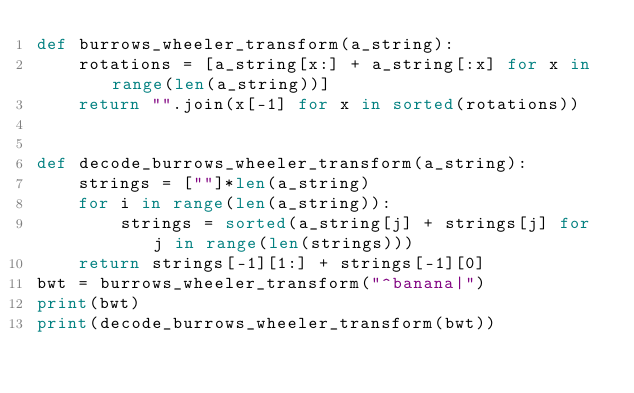Convert code to text. <code><loc_0><loc_0><loc_500><loc_500><_Python_>def burrows_wheeler_transform(a_string):
    rotations = [a_string[x:] + a_string[:x] for x in range(len(a_string))]
    return "".join(x[-1] for x in sorted(rotations))


def decode_burrows_wheeler_transform(a_string):
    strings = [""]*len(a_string)
    for i in range(len(a_string)):
        strings = sorted(a_string[j] + strings[j] for j in range(len(strings)))
    return strings[-1][1:] + strings[-1][0]
bwt = burrows_wheeler_transform("^banana|")
print(bwt)
print(decode_burrows_wheeler_transform(bwt))</code> 